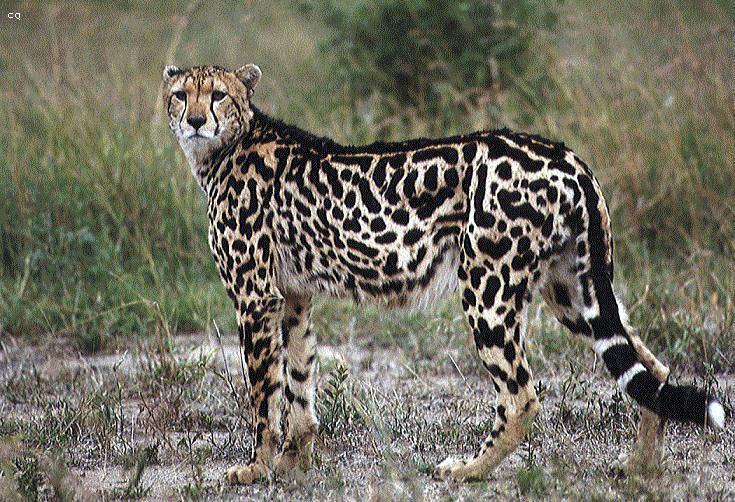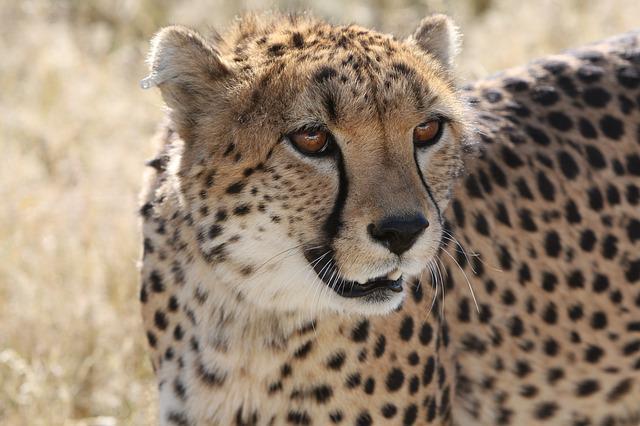The first image is the image on the left, the second image is the image on the right. Analyze the images presented: Is the assertion "There are at least 3 cheetahs in each image." valid? Answer yes or no. No. 